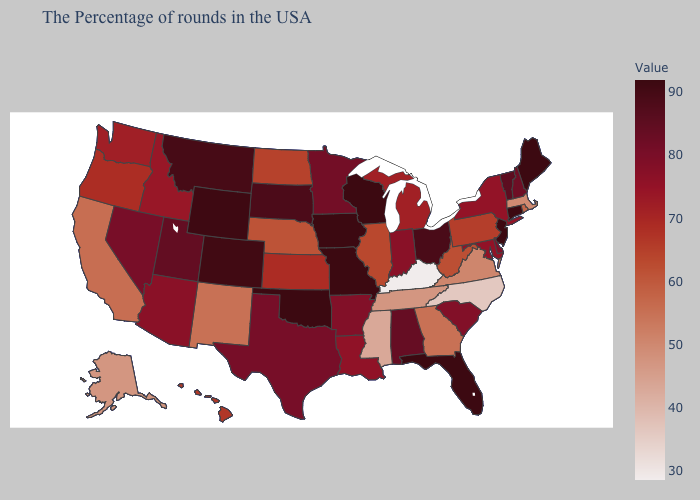Which states have the lowest value in the Northeast?
Quick response, please. Massachusetts. Does Kentucky have the lowest value in the USA?
Answer briefly. Yes. Which states hav the highest value in the South?
Give a very brief answer. Florida, Oklahoma. Which states have the lowest value in the USA?
Give a very brief answer. Kentucky. Does Tennessee have the highest value in the South?
Short answer required. No. Does North Dakota have a higher value than Louisiana?
Short answer required. No. 